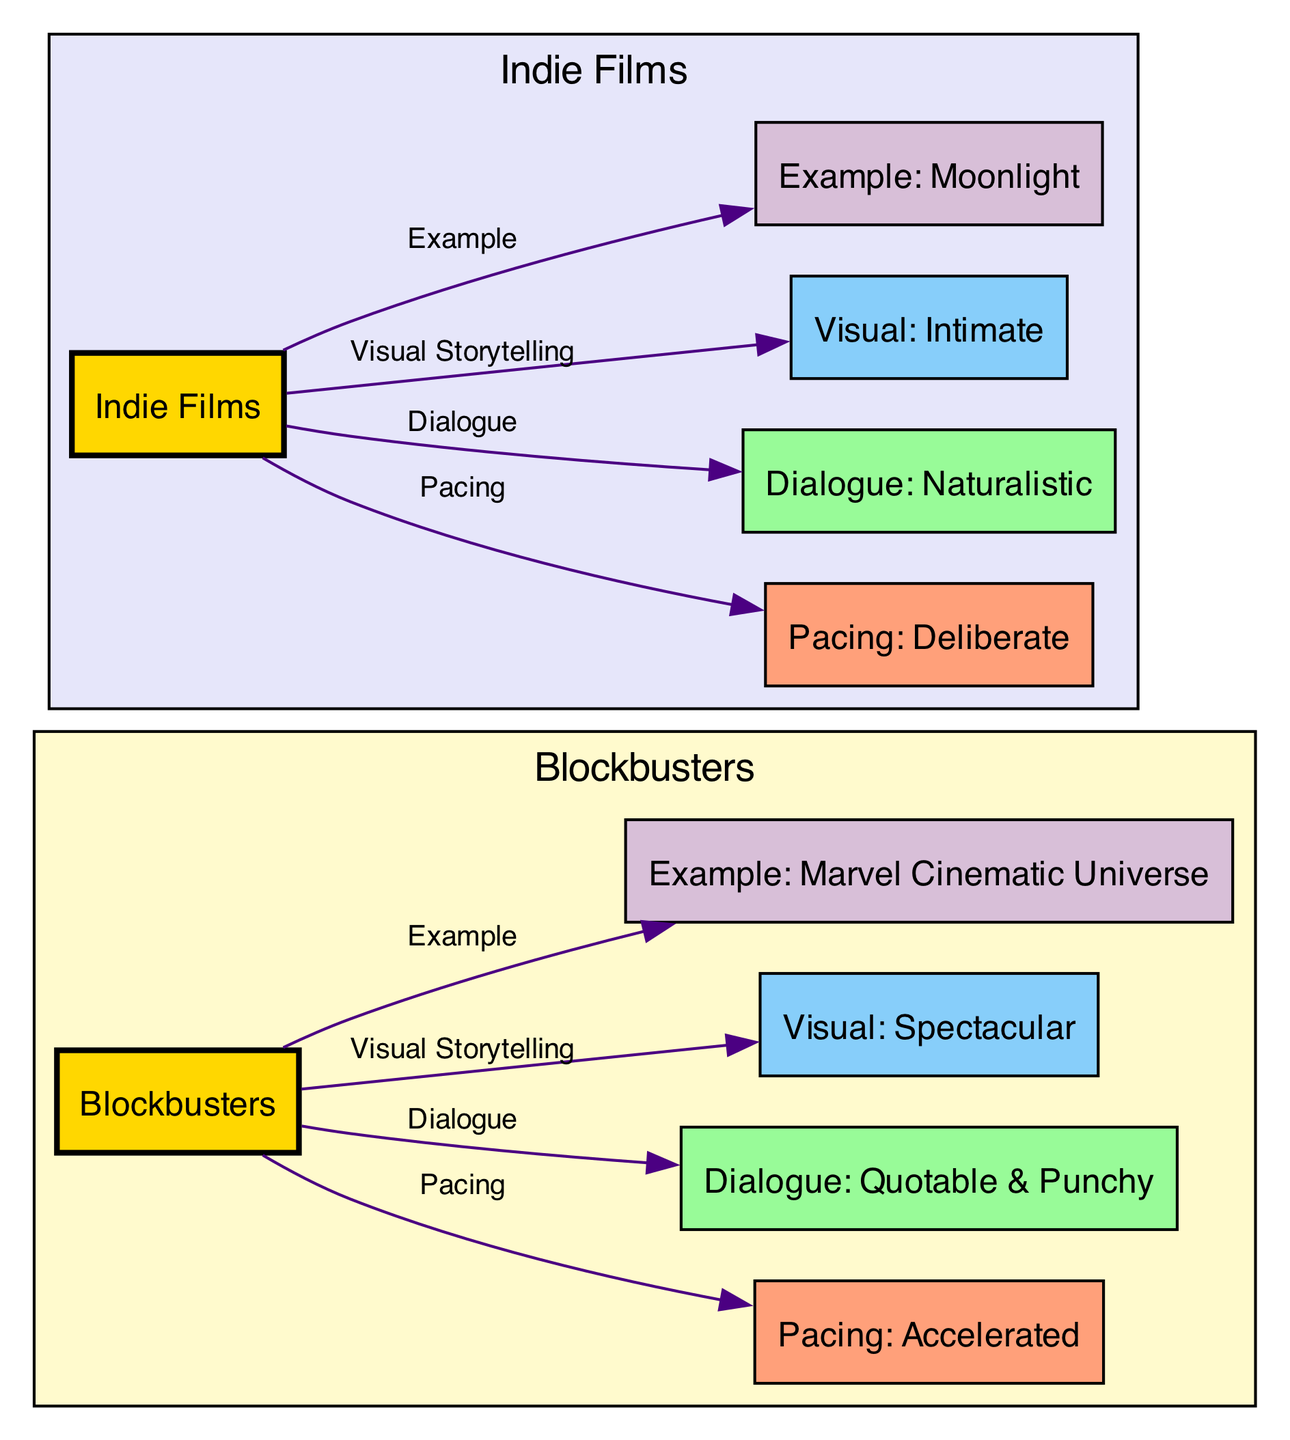What is the pacing description for blockbusters? The diagram specifically labels "Pacing: Accelerated" as the pacing description for blockbusters. This node can be found connected to the "Blockbusters" node via an edge labeled "Pacing."
Answer: Accelerated What is the dialogue style used in indie films? The diagram shows "Dialogue: Naturalistic" as the dialogue style for indie films. This information is contained within the node connected to the "Indie Films" node through an edge labeled "Dialogue."
Answer: Naturalistic How many nodes represent examples of the respective film types? The diagram contains two example nodes: "Example: Marvel Cinematic Universe" for blockbusters and "Example: Moonlight" for indie films. Therefore, the total number of example nodes is two.
Answer: 2 What type of visual storytelling is associated with indie films? The node linked to the "Indie Films" node indicates "Visual: Intimate" as the type of visual storytelling. This connection is revealed by the edge labeled "Visual Storytelling."
Answer: Intimate Which film example is associated with blockbusters? According to the diagram, "Example: Marvel Cinematic Universe" is the specific example linked with blockbusters. This is directly connected to the "Blockbusters" node with a labeled edge.
Answer: Marvel Cinematic Universe Which narrative element is described as “Quotable & Punchy”? The diagram labels "Dialogue: Quotable & Punchy" specifically for blockbusters, reflecting the distinct narrative style. This description is connected to the "Blockbusters" node through an edge labeled "Dialogue."
Answer: Quotable & Punchy How are the visual storytelling techniques different between blockbusters and indie films? The diagram highlights two contrasting nodes: "Visual: Spectacular" for blockbusters and "Visual: Intimate" for indie films. This visual disparity is illustrated by the edges connecting their respective nodes.
Answer: Spectacular and Intimate What edge connects indie films with pacing? The edge labeled "Pacing" specifically connects the "Indie Films" node to the "Pacing: Deliberate" node, indicating the pacing style associated with indie films.
Answer: Pacing What is the color representing the pacing for blockbusters? In the diagram, the node for pacing of blockbusters is colored with a salmon shade (#FFA07A), which visually distinguishes it from other types.
Answer: Salmon shade 